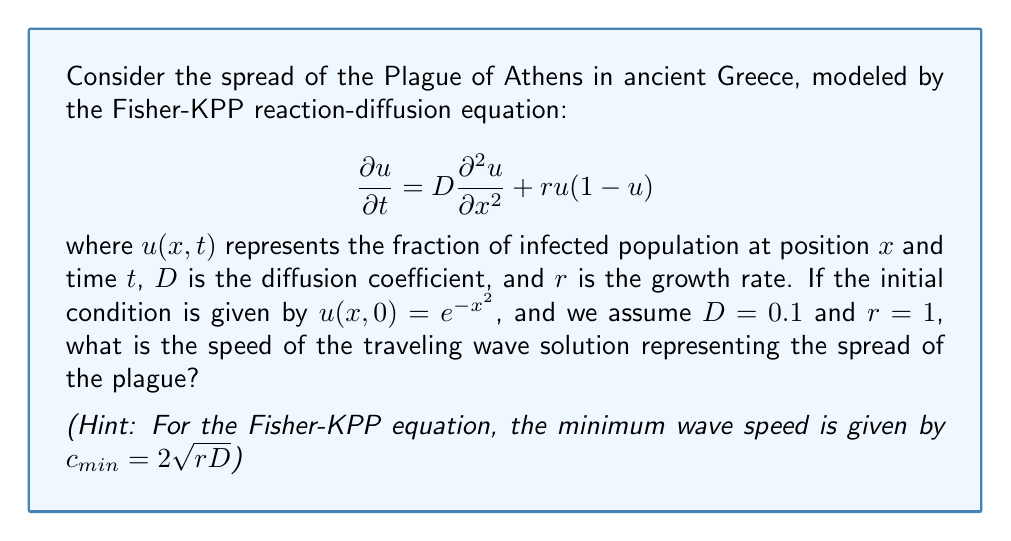Give your solution to this math problem. To solve this problem, we'll follow these steps:

1) First, let's recall that the Fisher-KPP equation is a reaction-diffusion equation that models the spread of a population (in this case, the infected population during the Plague of Athens).

2) The equation given is:

   $$\frac{\partial u}{\partial t} = D\frac{\partial^2 u}{\partial x^2} + ru(1-u)$$

   Here, the first term on the right-hand side represents diffusion, and the second term represents logistic growth.

3) We're given that $D=0.1$ and $r=1$. These parameters represent:
   - $D$: the diffusion coefficient, which measures how quickly the infected population spreads spatially.
   - $r$: the growth rate of the infected population.

4) The initial condition $u(x,0) = e^{-x^2}$ represents a Gaussian distribution of the infected population at time $t=0$. This could represent an initial outbreak centered at $x=0$.

5) For the Fisher-KPP equation, it's known that solutions evolve into traveling waves for a wide range of initial conditions. These waves represent the advancing front of the infection.

6) The minimum wave speed for the Fisher-KPP equation is given by:

   $$c_{min} = 2\sqrt{rD}$$

7) Substituting our values:

   $$c_{min} = 2\sqrt{1 \cdot 0.1} = 2\sqrt{0.1} = 2 \cdot 0.3162 = 0.6324$$

8) This speed represents the rate at which the plague would spread through the population in this model.
Answer: The speed of the traveling wave solution representing the spread of the plague is approximately 0.6324 units of distance per unit of time. 